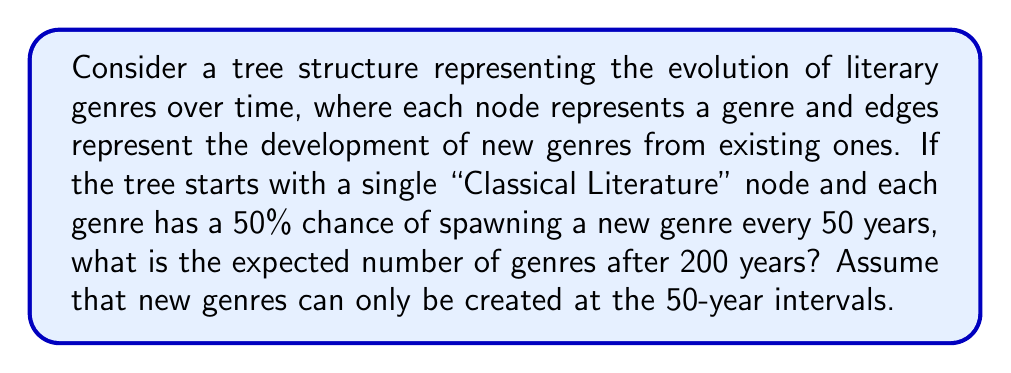Teach me how to tackle this problem. To solve this problem, we need to consider the growth of the tree structure over time. Let's break it down step by step:

1. We start with 1 node (Classical Literature) at year 0.

2. Every 50 years, each existing node has a 50% chance of spawning a new genre.

3. We need to calculate this for 4 time steps (200 years / 50 years per step = 4 steps).

Let's define $E_n$ as the expected number of nodes after $n$ steps.

At each step, the expected number of new nodes is half the current number of nodes:

$$E_{n+1} = E_n + \frac{1}{2}E_n = \frac{3}{2}E_n$$

Starting with $E_0 = 1$, we can calculate:

$$E_1 = \frac{3}{2} \cdot 1 = 1.5$$
$$E_2 = \frac{3}{2} \cdot 1.5 = 2.25$$
$$E_3 = \frac{3}{2} \cdot 2.25 = 3.375$$
$$E_4 = \frac{3}{2} \cdot 3.375 = 5.0625$$

Therefore, after 200 years (4 steps), the expected number of genres is 5.0625.

This growth pattern follows a geometric sequence with a common ratio of $\frac{3}{2}$. We can express this mathematically as:

$$E_n = \left(\frac{3}{2}\right)^n$$

For $n = 4$:

$$E_4 = \left(\frac{3}{2}\right)^4 = 5.0625$$

This confirms our step-by-step calculation.
Answer: The expected number of literary genres after 200 years is 5.0625. 